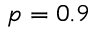Convert formula to latex. <formula><loc_0><loc_0><loc_500><loc_500>p = 0 . 9</formula> 